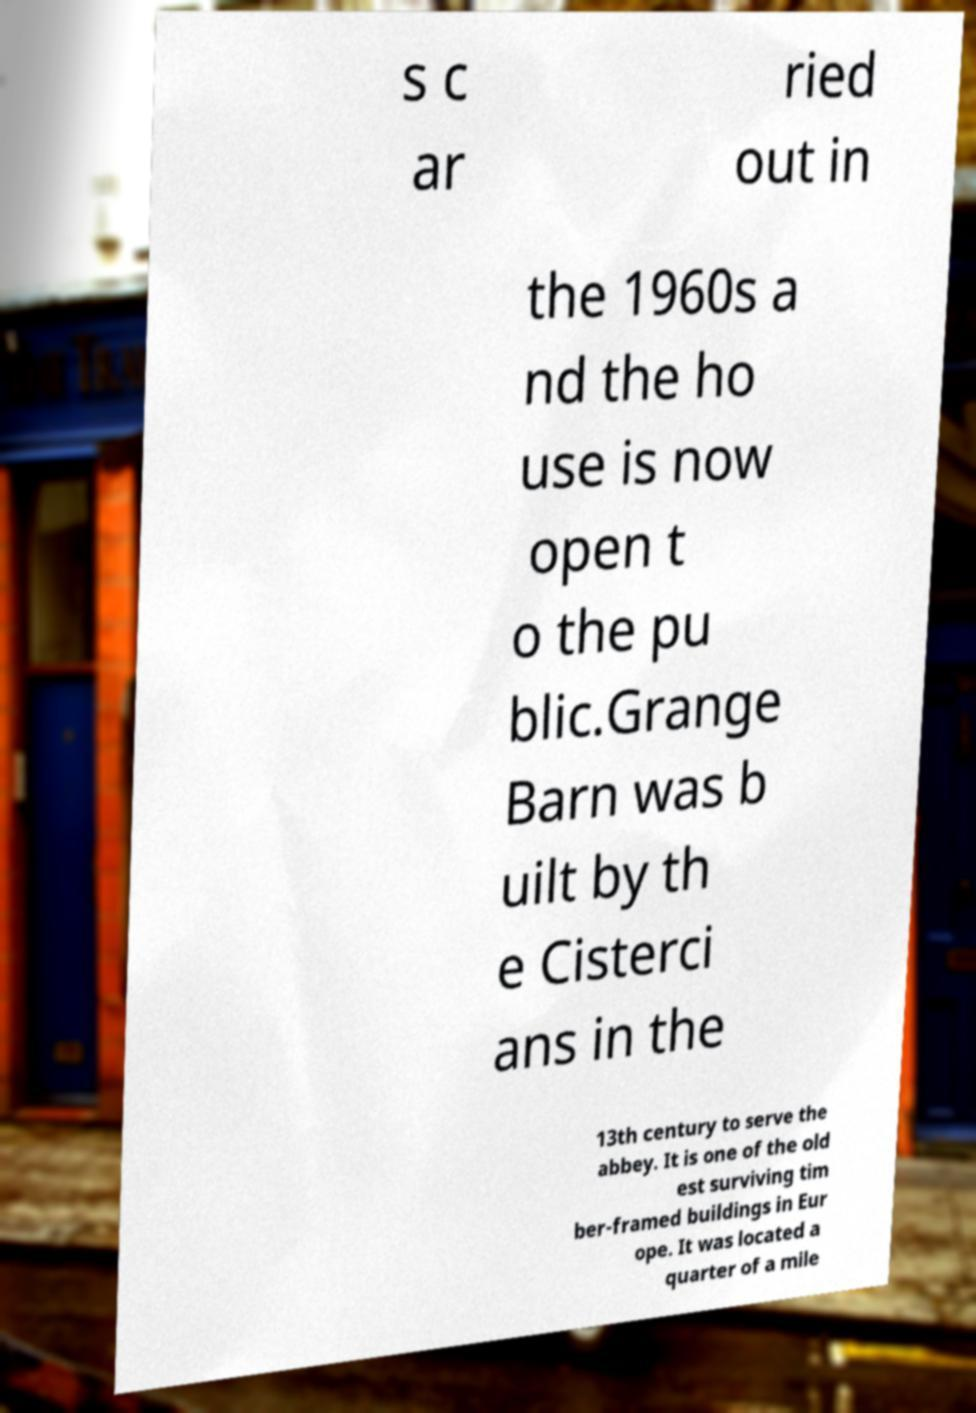I need the written content from this picture converted into text. Can you do that? s c ar ried out in the 1960s a nd the ho use is now open t o the pu blic.Grange Barn was b uilt by th e Cisterci ans in the 13th century to serve the abbey. It is one of the old est surviving tim ber-framed buildings in Eur ope. It was located a quarter of a mile 